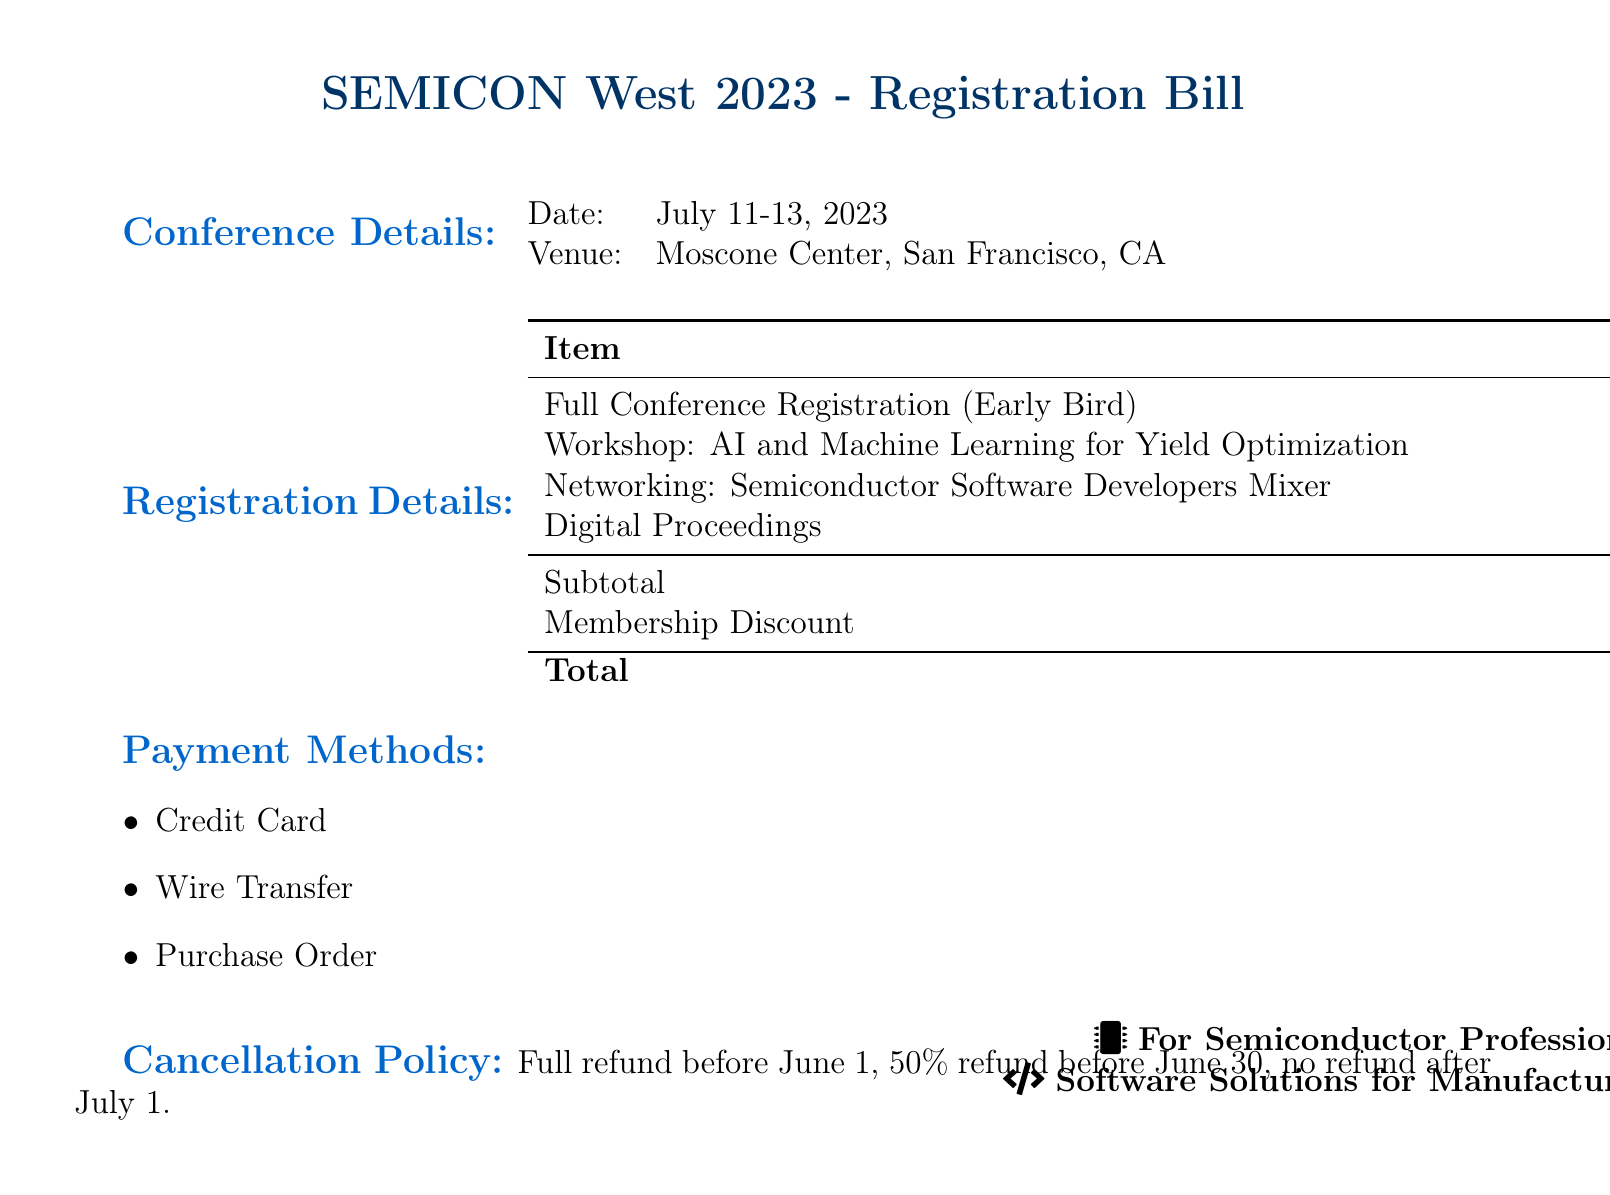What is the total registration cost? The total registration cost is the sum of all costs listed in the registration details, which is $2,335.00 - $100.00.
Answer: $2,235.00 Where is the venue located? The venue for the conference is specified in the document as the Moscone Center, San Francisco, CA.
Answer: Moscone Center, San Francisco, CA What is the cost of the workshop on AI and Machine Learning? The workshop cost is explicitly listed in the document under registration details.
Answer: $795.00 What is the date range of the conference? The date range is provided in the conference details section of the document.
Answer: July 11-13, 2023 How much is the membership discount? The membership discount is mentioned specifically in the registration details.
Answer: $100.00 What type of payment methods are accepted? The document lists three accepted payment methods under the payment methods section.
Answer: Credit Card, Wire Transfer, Purchase Order What is the cancellation policy for refunds? The cancellation policy for refunds is clearly stated in the document, indicating important dates and percentage refunds.
Answer: Full refund before June 1, 50% refund before June 30, no refund after July 1 What is the cost for the networking session? The networking session cost is listed in the registration details section of the document.
Answer: $150.00 What is included in the subtotal before any discounts? The subtotal can be calculated from the total of all the costs before the membership discount is applied.
Answer: $2,335.00 What icon is associated with semiconductor professionals? The document includes an icon representation specific to semiconductor professionals at the bottom.
Answer: Microchip 